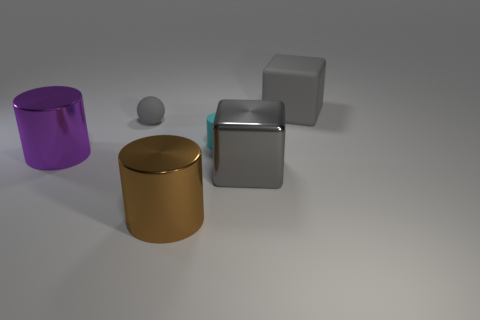Can you tell me about the colors of the objects in the image? Certainly! In the image, we see objects with different colors: a purple cylinder, a metallic gold cylinder, a matte gray cube, and a small, matte gray sphere. 